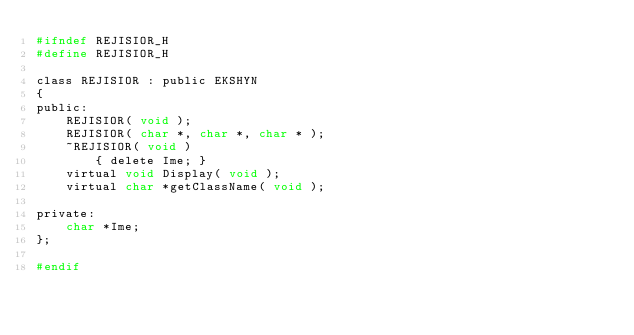Convert code to text. <code><loc_0><loc_0><loc_500><loc_500><_C_>#ifndef REJISIOR_H
#define REJISIOR_H

class REJISIOR : public EKSHYN
{
public:
	REJISIOR( void );						
	REJISIOR( char *, char *, char * );		
	~REJISIOR( void )							
		{ delete Ime; }	
	virtual void Display( void );
	virtual char *getClassName( void );

private:
	char *Ime;
};

#endif</code> 